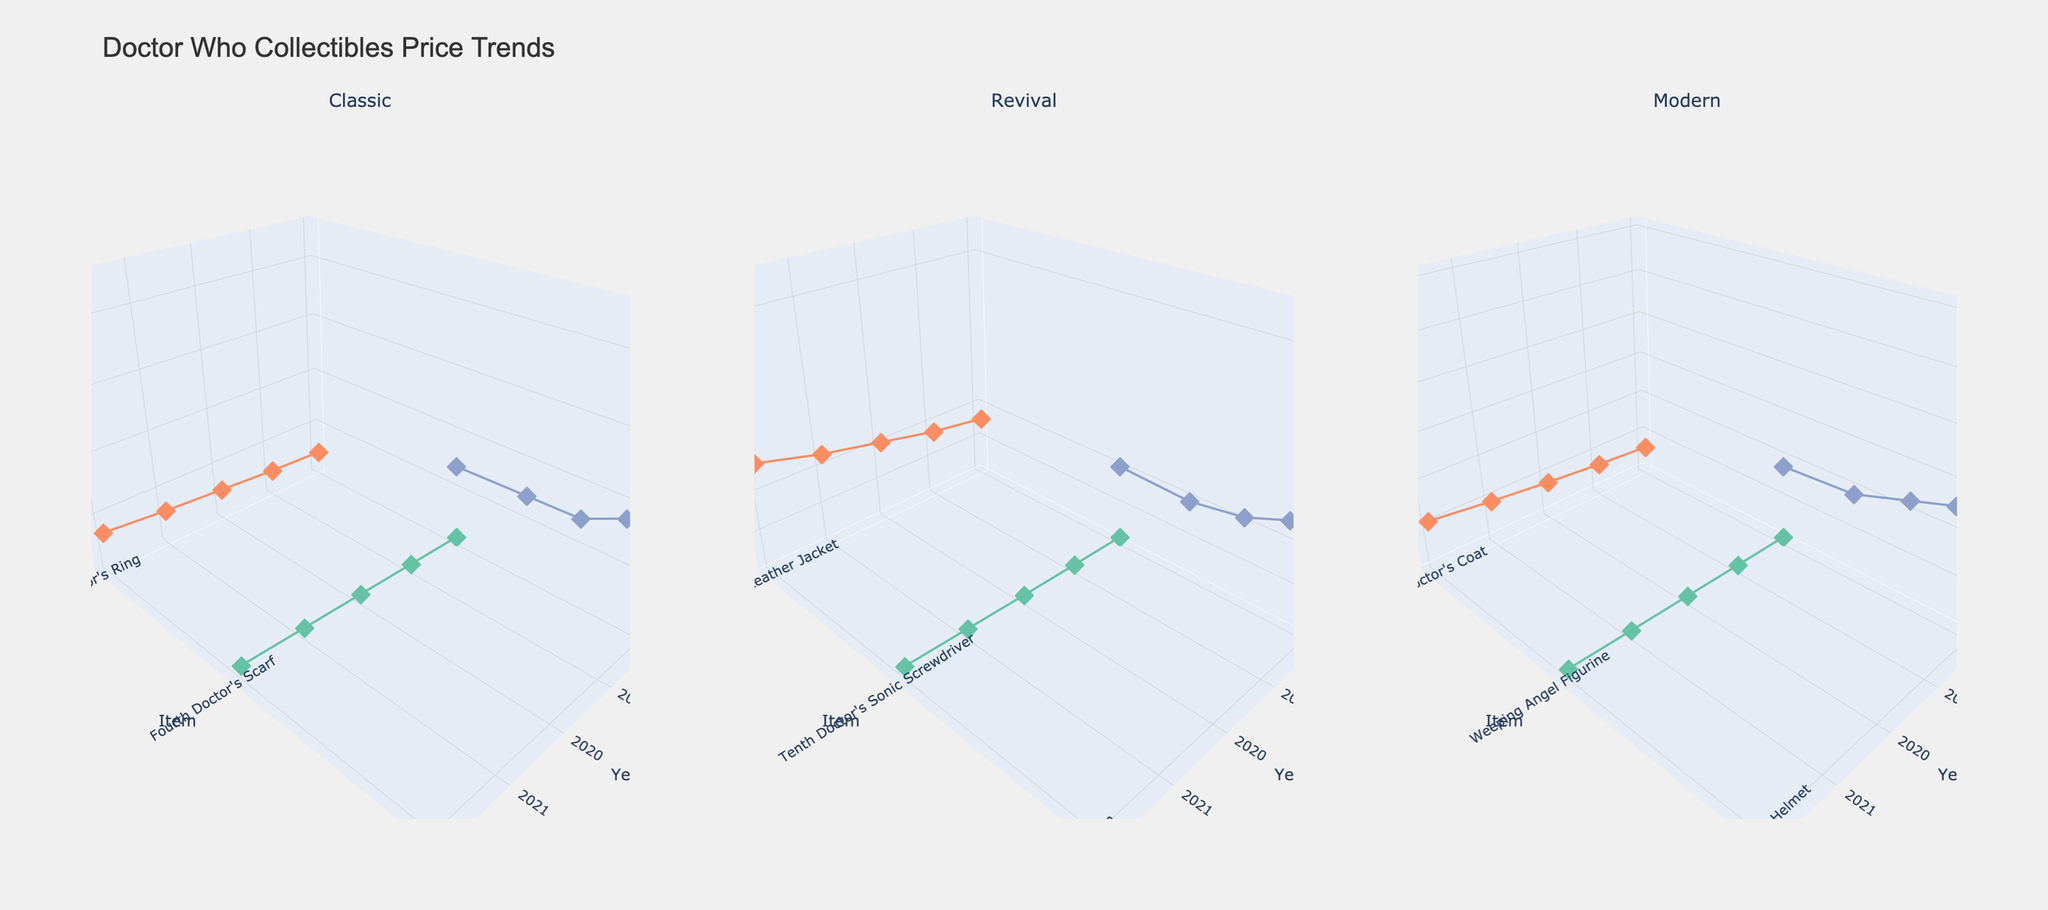What is the title of the plot? The title of the plot is prominently displayed at the top of the figure, which reads "Doctor Who Collectibles Price Trends".
Answer: Doctor Who Collectibles Price Trends What are the three eras shown in the subplots? Each subplot is labeled with the title of an era: Classic, Revival, and Modern.
Answer: Classic, Revival, Modern Which rarity level appears to have had the highest price increase in the Classic era? By observing the plot for the Classic era, the "Ultra Rare" category (Dalek Prop) shows the highest price increase, starting around $2000 and rising to $4500.
Answer: Ultra Rare For the Revival era, what is the price trend for the TARDIS Door Sign? In the subplot for the Revival era, the TARDIS Door Sign shows a consistent price increase from $1500 in 2018 to $3300 in 2022.
Answer: Increasing In the Modern era, how does the price of Thirteenth Doctor's Coat compare to Weeping Angel Figurine in 2022? In the Modern era subplot, the price of Thirteenth Doctor's Coat in 2022 is $1150, while the price of the Weeping Angel Figurine is $110.
Answer: Thirteenth Doctor's Coat is higher Which item had the highest price in 2022 across all eras? By comparing the highest points in the 2022 data across all subplots, the "Screen-Used Cyberman Helmet" in the Modern era has the highest price at $6000.
Answer: Screen-Used Cyberman Helmet If you look at the Fourth Doctor's Scarf in the Classic era, by how much did the price increase from 2018 to 2022? The price of the Fourth Doctor's Scarf in the Classic era increased from $150 in 2018 to $250 in 2022. The increase is calculated as $250 - $150 = $100.
Answer: $100 Between the Ninth Doctor's Leather Jacket and Tenth Doctor's Sonic Screwdriver in the Revival era, which had a steeper price increase from 2018 to 2022? The Ninth Doctor's Leather Jacket increased from $800 to $1400 ($600 increase), and the Tenth Doctor's Sonic Screwdriver increased from $75 to $140 ($65 increase). The Ninth Doctor's Leather Jacket had a steeper price increase.
Answer: Ninth Doctor's Leather Jacket What color represents the "Common" rarity across all three subplots? The "Common" rarity is represented by a light green color in all three subplots.
Answer: Light Green 